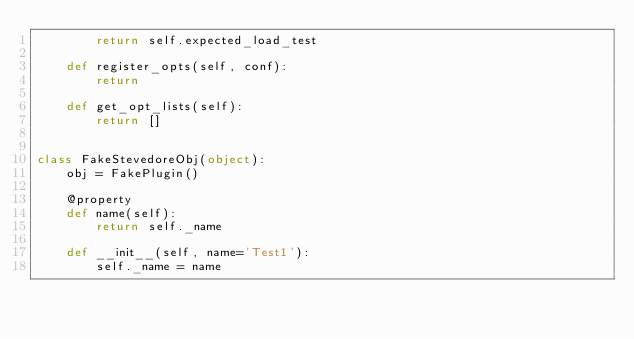<code> <loc_0><loc_0><loc_500><loc_500><_Python_>        return self.expected_load_test

    def register_opts(self, conf):
        return

    def get_opt_lists(self):
        return []


class FakeStevedoreObj(object):
    obj = FakePlugin()

    @property
    def name(self):
        return self._name

    def __init__(self, name='Test1'):
        self._name = name
</code> 